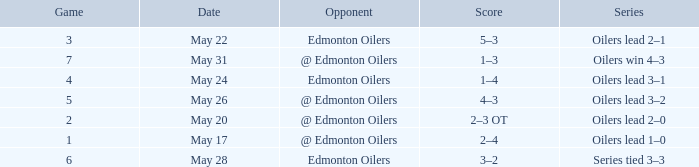Could you help me parse every detail presented in this table? {'header': ['Game', 'Date', 'Opponent', 'Score', 'Series'], 'rows': [['3', 'May 22', 'Edmonton Oilers', '5–3', 'Oilers lead 2–1'], ['7', 'May 31', '@ Edmonton Oilers', '1–3', 'Oilers win 4–3'], ['4', 'May 24', 'Edmonton Oilers', '1–4', 'Oilers lead 3–1'], ['5', 'May 26', '@ Edmonton Oilers', '4–3', 'Oilers lead 3–2'], ['2', 'May 20', '@ Edmonton Oilers', '2–3 OT', 'Oilers lead 2–0'], ['1', 'May 17', '@ Edmonton Oilers', '2–4', 'Oilers lead 1–0'], ['6', 'May 28', 'Edmonton Oilers', '3–2', 'Series tied 3–3']]} Competitor against edmonton oilers, and a collection of 3 games belongs to which series? Oilers lead 2–1. 